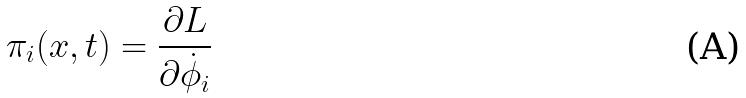<formula> <loc_0><loc_0><loc_500><loc_500>\pi _ { i } ( x , t ) = \frac { \partial L } { \partial \dot { \phi } _ { i } }</formula> 